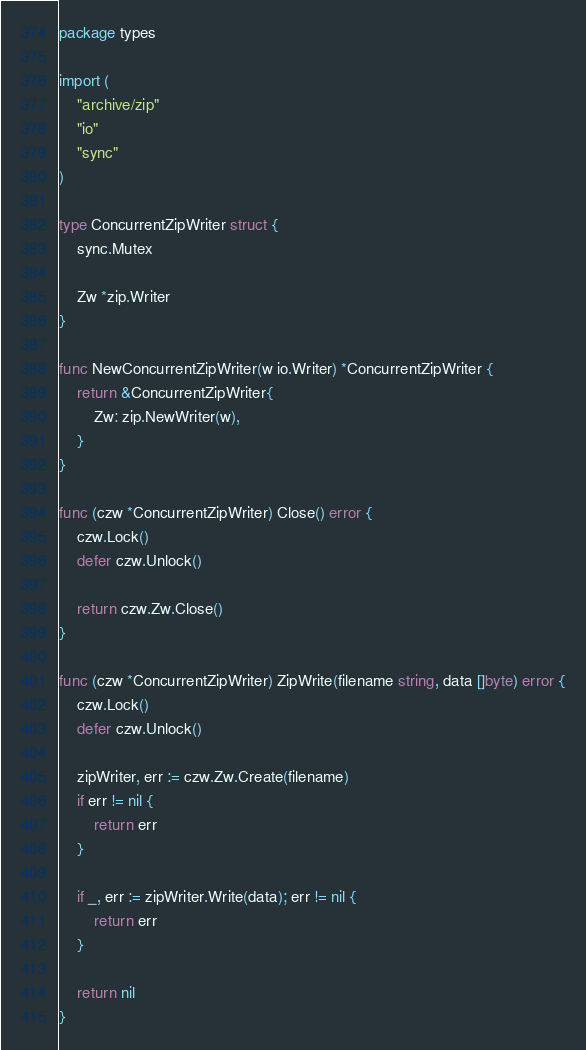Convert code to text. <code><loc_0><loc_0><loc_500><loc_500><_Go_>package types

import (
	"archive/zip"
	"io"
	"sync"
)

type ConcurrentZipWriter struct {
	sync.Mutex

	Zw *zip.Writer
}

func NewConcurrentZipWriter(w io.Writer) *ConcurrentZipWriter {
	return &ConcurrentZipWriter{
		Zw: zip.NewWriter(w),
	}
}

func (czw *ConcurrentZipWriter) Close() error {
	czw.Lock()
	defer czw.Unlock()

	return czw.Zw.Close()
}

func (czw *ConcurrentZipWriter) ZipWrite(filename string, data []byte) error {
	czw.Lock()
	defer czw.Unlock()

	zipWriter, err := czw.Zw.Create(filename)
	if err != nil {
		return err
	}

	if _, err := zipWriter.Write(data); err != nil {
		return err
	}

	return nil
}
</code> 